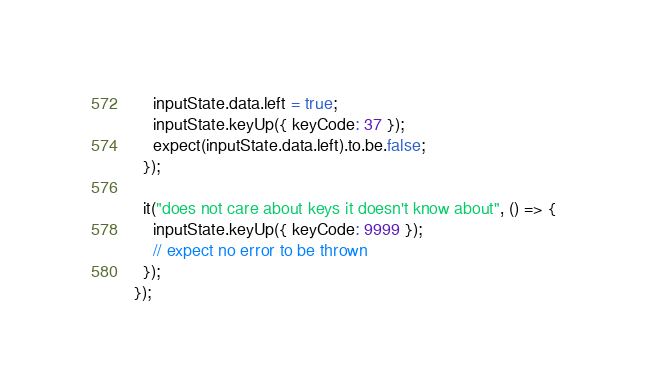Convert code to text. <code><loc_0><loc_0><loc_500><loc_500><_JavaScript_>    inputState.data.left = true;
    inputState.keyUp({ keyCode: 37 });
    expect(inputState.data.left).to.be.false;
  });

  it("does not care about keys it doesn't know about", () => {
    inputState.keyUp({ keyCode: 9999 });
    // expect no error to be thrown
  });
});
</code> 